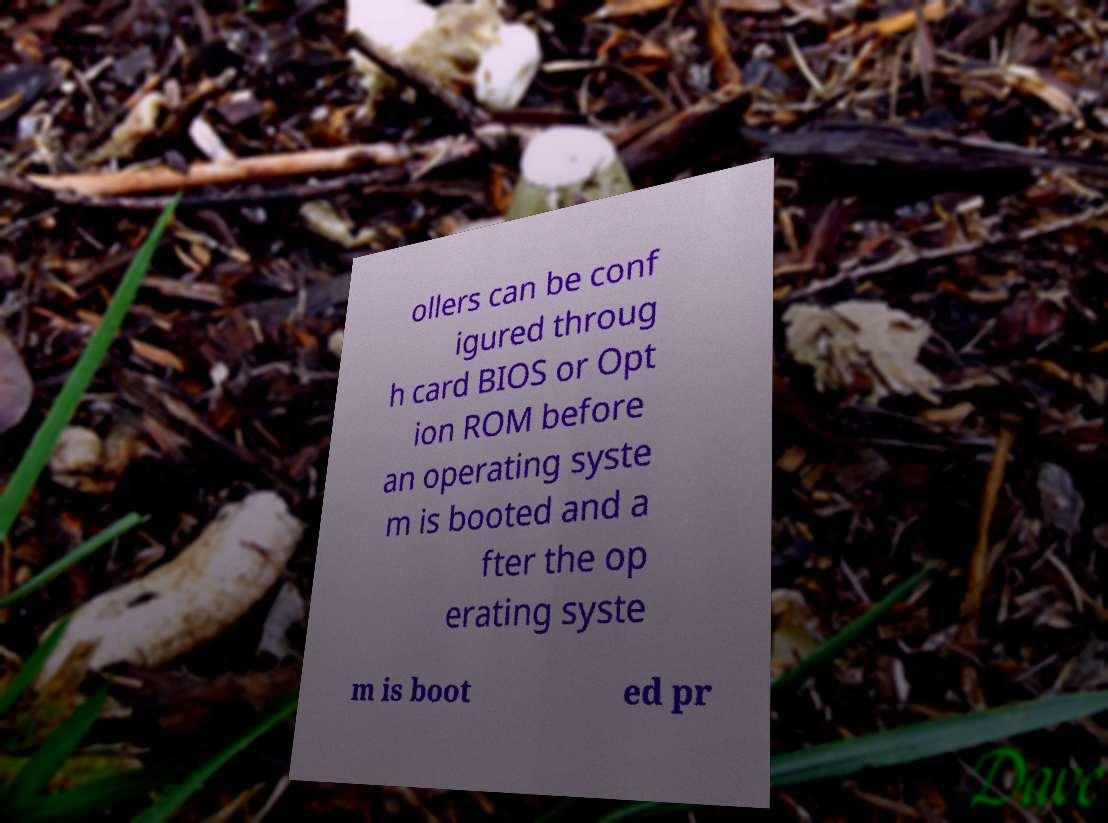For documentation purposes, I need the text within this image transcribed. Could you provide that? ollers can be conf igured throug h card BIOS or Opt ion ROM before an operating syste m is booted and a fter the op erating syste m is boot ed pr 